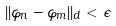Convert formula to latex. <formula><loc_0><loc_0><loc_500><loc_500>| | \varphi _ { n } - \varphi _ { m } | | _ { d } < \epsilon</formula> 